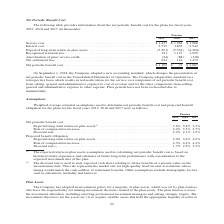From Jabil Circuit's financial document, Which fiscal years does the table provide information about the net periodic benefit cost for? The document contains multiple relevant values: 2019, 2018, 2017. From the document: "2019 2018 2017 2019 2018 2017 2019 2018 2017..." Also, What was the service cost in 2019? According to the financial document, $1,437 (in thousands). The relevant text states: "Service cost . $ 1,437 $ 1,063 $ 1,068 Interest cost . 3,715 3,807 2,942 Expected long-term return on plan assets . (5,291..." Also, What was the interest cost in 2018? According to the financial document, 3,807 (in thousands). The relevant text states: "t . $ 1,437 $ 1,063 $ 1,068 Interest cost . 3,715 3,807 2,942 Expected long-term return on plan assets . (5,291) (5,954) (4,206) Recognized actuarial loss..." Also, can you calculate: What was the change in interest cost between 2018 and 2019? Based on the calculation: 3,715-3,807, the result is -92 (in thousands). This is based on the information: "t . $ 1,437 $ 1,063 $ 1,068 Interest cost . 3,715 3,807 2,942 Expected long-term return on plan assets . (5,291) (5,954) (4,206) Recognized actuarial loss ce cost . $ 1,437 $ 1,063 $ 1,068 Interest co..." The key data points involved are: 3,715, 3,807. Also, How many years did the recognized actuarial loss exceed $1,000 thousand? Counting the relevant items in the document: 2018, 2017, I find 2 instances. The key data points involved are: 2017, 2018. Also, can you calculate: What was the total percentage change in the Net periodic benefit cost between 2017 and 2019? To answer this question, I need to perform calculations using the financial data. The calculation is: ($1,192-$3,067)/$3,067, which equals -61.13 (percentage). This is based on the information: "Net periodic benefit cost . $ 1,192 $ 71 $ 3,067 Net periodic benefit cost . $ 1,192 $ 71 $ 3,067..." The key data points involved are: 1,192, 3,067. 